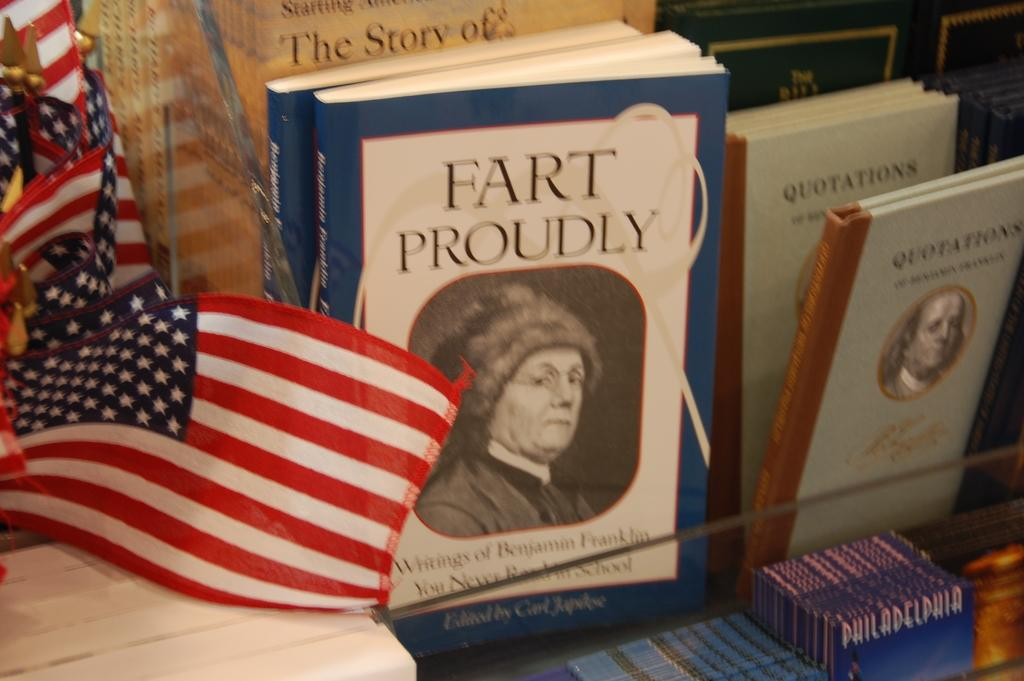<image>
Create a compact narrative representing the image presented. a book by an american flag that says fart proudly 